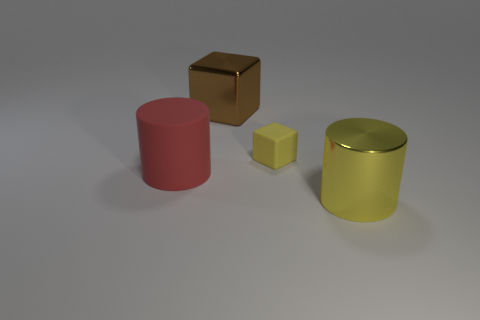How many other tiny rubber objects have the same shape as the brown object?
Give a very brief answer. 1. What shape is the big metallic thing behind the big cylinder on the left side of the shiny object that is behind the large red rubber cylinder?
Offer a terse response. Cube. What is the large thing that is both on the left side of the yellow cube and in front of the shiny cube made of?
Offer a terse response. Rubber. There is a cylinder that is to the left of the brown metal cube; does it have the same size as the metal block?
Provide a succinct answer. Yes. Are there any other things that have the same size as the yellow cube?
Offer a very short reply. No. Is the number of brown blocks that are in front of the big brown block greater than the number of big yellow cylinders that are on the left side of the large yellow metallic thing?
Your response must be concise. No. What color is the rubber thing behind the rubber object on the left side of the yellow thing behind the red matte cylinder?
Make the answer very short. Yellow. There is a large thing that is in front of the red object; is its color the same as the matte cylinder?
Give a very brief answer. No. What number of other objects are there of the same color as the big shiny cylinder?
Provide a short and direct response. 1. How many objects are either yellow rubber cubes or big yellow cylinders?
Your response must be concise. 2. 